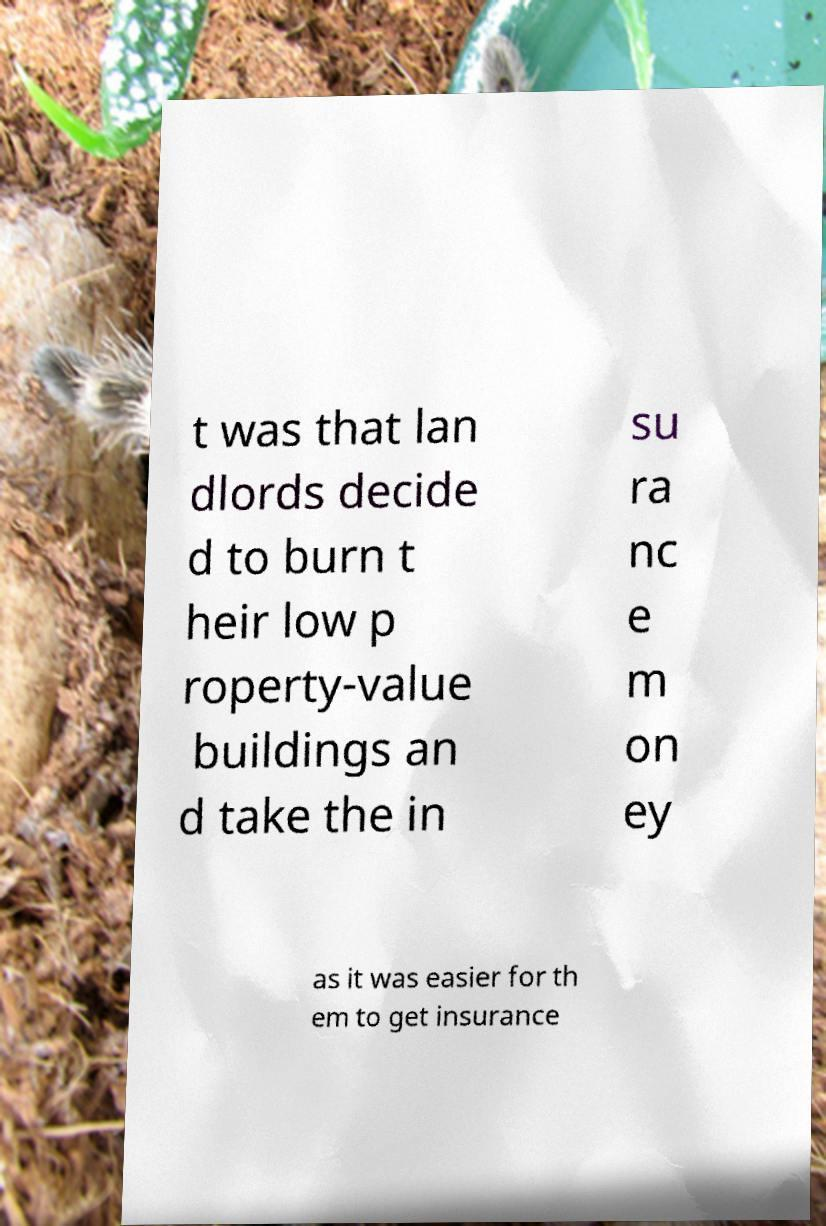There's text embedded in this image that I need extracted. Can you transcribe it verbatim? t was that lan dlords decide d to burn t heir low p roperty-value buildings an d take the in su ra nc e m on ey as it was easier for th em to get insurance 